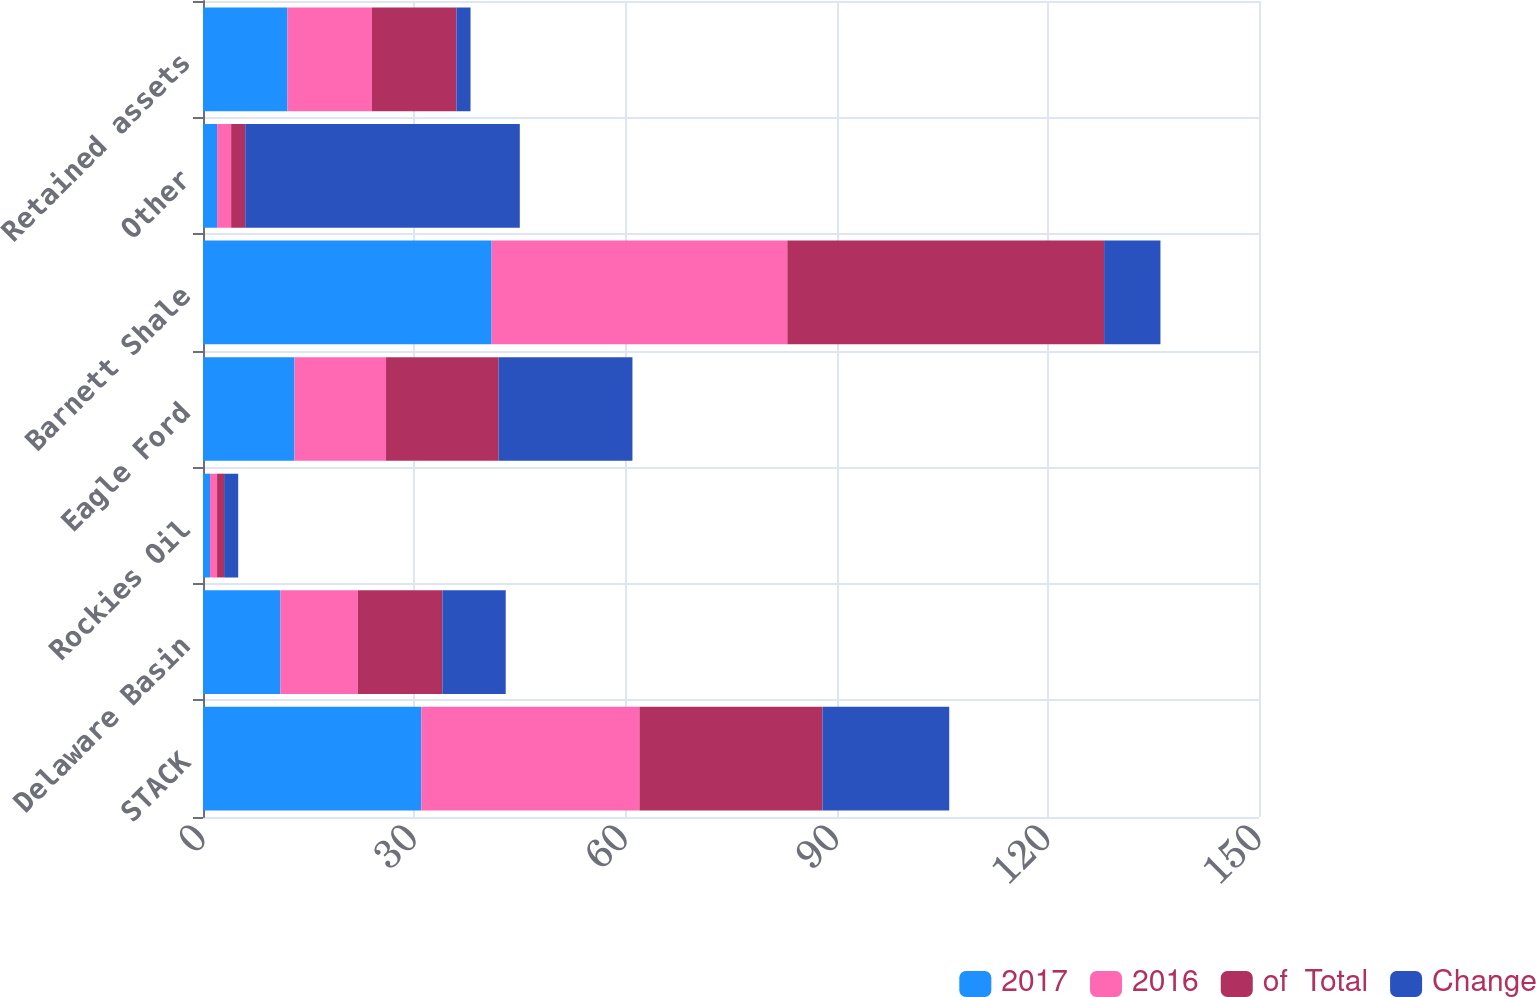Convert chart to OTSL. <chart><loc_0><loc_0><loc_500><loc_500><stacked_bar_chart><ecel><fcel>STACK<fcel>Delaware Basin<fcel>Rockies Oil<fcel>Eagle Ford<fcel>Barnett Shale<fcel>Other<fcel>Retained assets<nl><fcel>2017<fcel>31<fcel>11<fcel>1<fcel>13<fcel>41<fcel>2<fcel>12<nl><fcel>2016<fcel>31<fcel>11<fcel>1<fcel>13<fcel>42<fcel>2<fcel>12<nl><fcel>of  Total<fcel>26<fcel>12<fcel>1<fcel>16<fcel>45<fcel>2<fcel>12<nl><fcel>Change<fcel>18<fcel>9<fcel>2<fcel>19<fcel>8<fcel>39<fcel>2<nl></chart> 